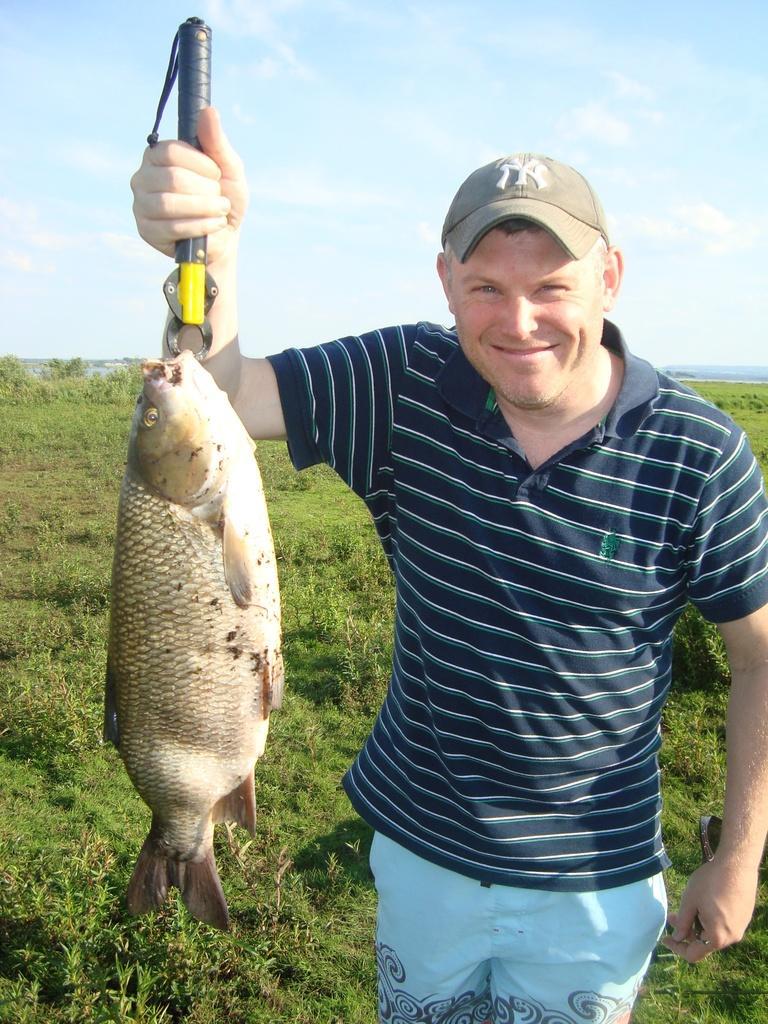Please provide a concise description of this image. There is a person wearing a cap is standing and holding a fish with some tool. In the back there is sky. On the ground there are grasses. 